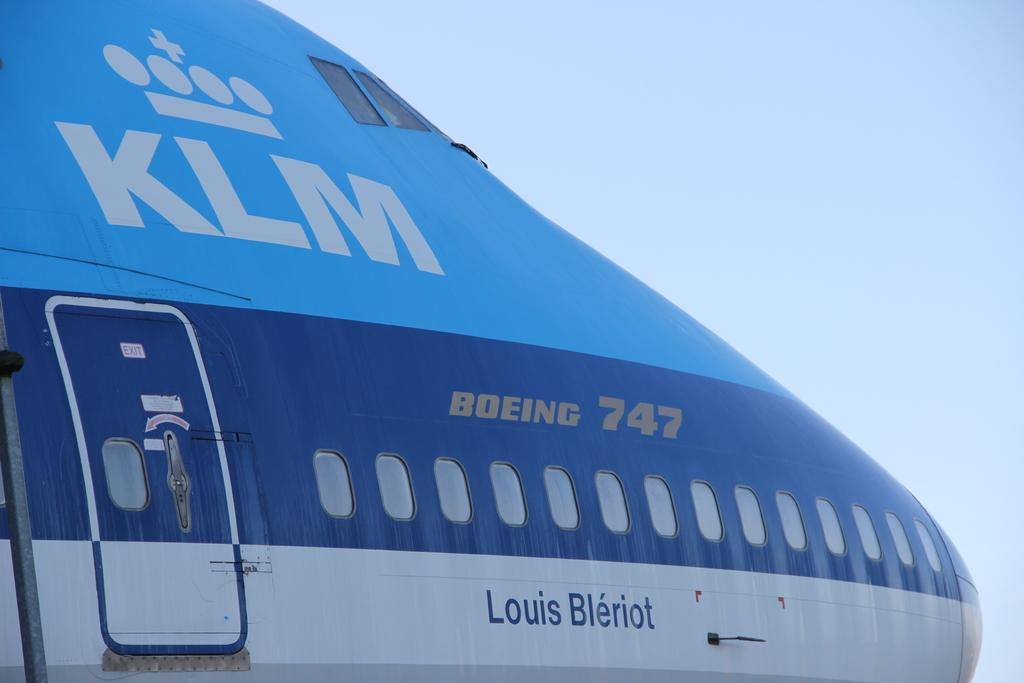What is the main subject of the image? The main subject of the image is an aircraft. What color is the aircraft? The aircraft is blue in color. What can be seen in the background of the image? The sky is visible in the background of the image. What color is the sky? The sky is white in color. How many sticks are being used for growth in the image? There are no sticks or growth-related activities depicted in the image; it features an aircraft and a white sky. 